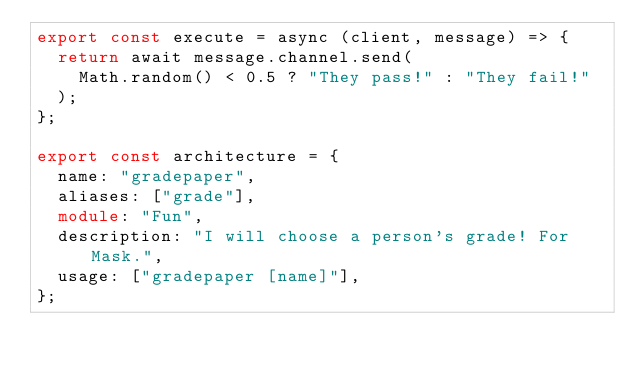<code> <loc_0><loc_0><loc_500><loc_500><_TypeScript_>export const execute = async (client, message) => {
  return await message.channel.send(
    Math.random() < 0.5 ? "They pass!" : "They fail!"
  );
};

export const architecture = {
  name: "gradepaper",
  aliases: ["grade"],
  module: "Fun",
  description: "I will choose a person's grade! For Mask.",
  usage: ["gradepaper [name]"],
};
</code> 